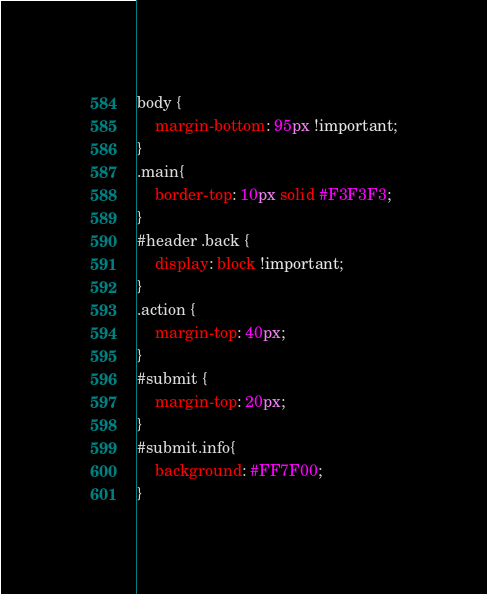Convert code to text. <code><loc_0><loc_0><loc_500><loc_500><_CSS_>body {
	margin-bottom: 95px !important;
}
.main{
	border-top: 10px solid #F3F3F3;
}
#header .back {
	display: block !important;
}
.action {
	margin-top: 40px;
}
#submit {
	margin-top: 20px;
}
#submit.info{
	background: #FF7F00;
}</code> 